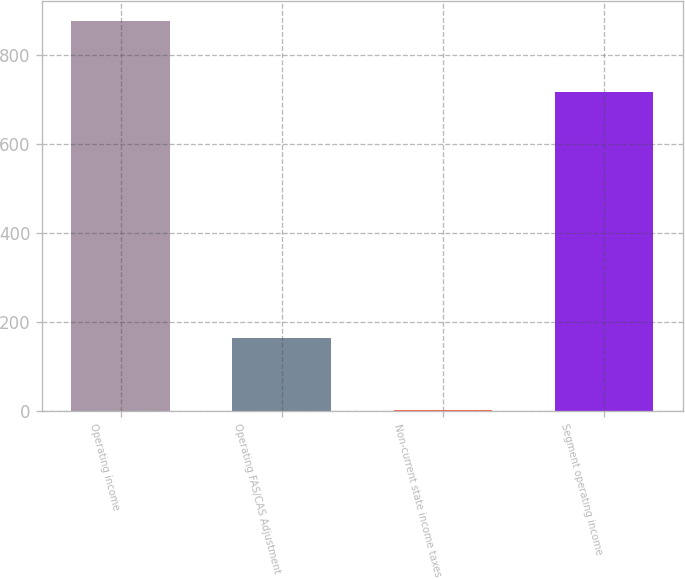<chart> <loc_0><loc_0><loc_500><loc_500><bar_chart><fcel>Operating income<fcel>Operating FAS/CAS Adjustment<fcel>Non-current state income taxes<fcel>Segment operating income<nl><fcel>876<fcel>163<fcel>2<fcel>715<nl></chart> 